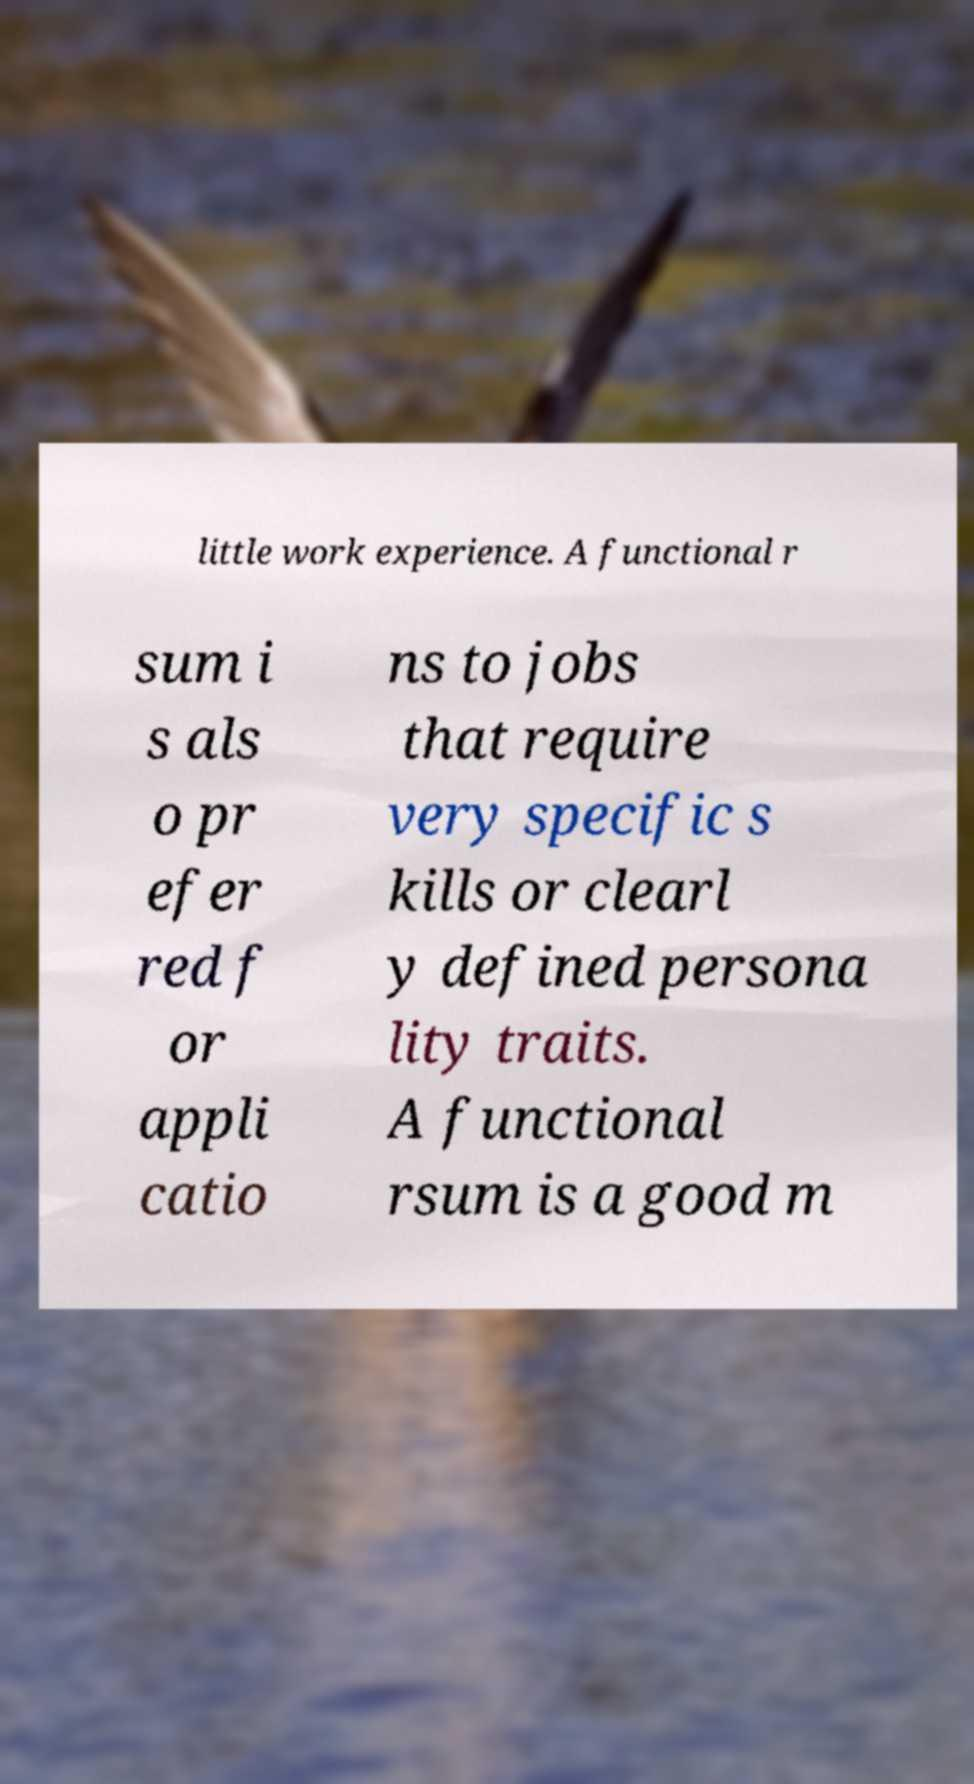Can you accurately transcribe the text from the provided image for me? little work experience. A functional r sum i s als o pr efer red f or appli catio ns to jobs that require very specific s kills or clearl y defined persona lity traits. A functional rsum is a good m 